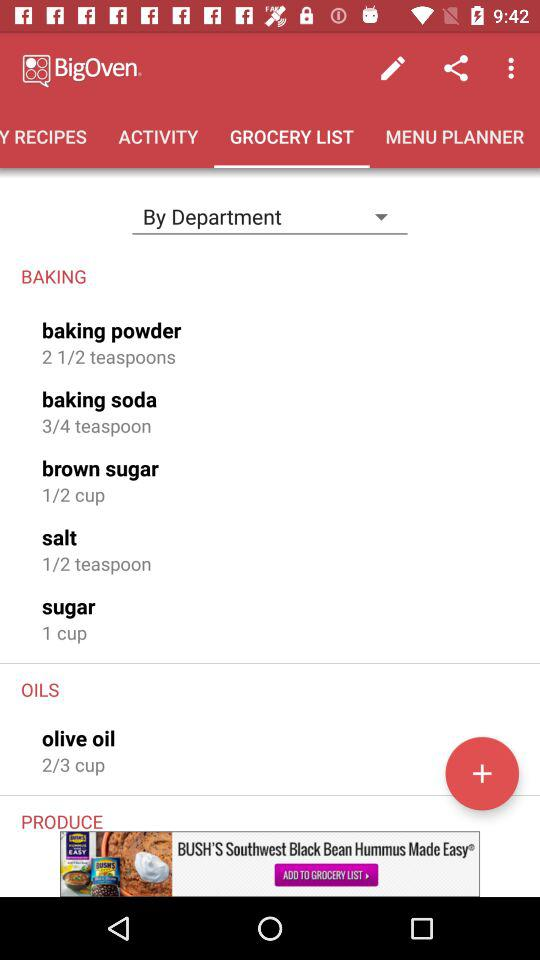How many teaspoons of baking powder are needed for this recipe?
Answer the question using a single word or phrase. 2 1/2 